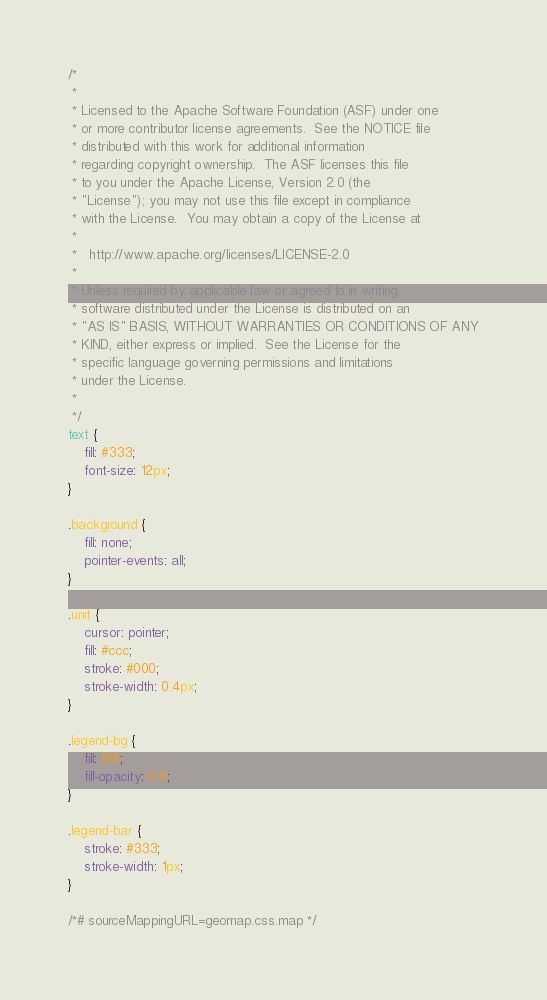Convert code to text. <code><loc_0><loc_0><loc_500><loc_500><_CSS_>/*
 *
 * Licensed to the Apache Software Foundation (ASF) under one
 * or more contributor license agreements.  See the NOTICE file
 * distributed with this work for additional information
 * regarding copyright ownership.  The ASF licenses this file
 * to you under the Apache License, Version 2.0 (the
 * "License"); you may not use this file except in compliance
 * with the License.  You may obtain a copy of the License at
 *
 *   http://www.apache.org/licenses/LICENSE-2.0
 *
 * Unless required by applicable law or agreed to in writing,
 * software distributed under the License is distributed on an
 * "AS IS" BASIS, WITHOUT WARRANTIES OR CONDITIONS OF ANY
 * KIND, either express or implied.  See the License for the
 * specific language governing permissions and limitations
 * under the License.
 *
 */
text {
    fill: #333;
    font-size: 12px;
}

.background {
    fill: none;
    pointer-events: all;
}

.unit {
    cursor: pointer;
    fill: #ccc;
    stroke: #000;
    stroke-width: 0.4px;
}

.legend-bg {
    fill: #fff;
    fill-opacity: 0.8;
}

.legend-bar {
    stroke: #333;
    stroke-width: 1px;
}

/*# sourceMappingURL=geomap.css.map */
</code> 